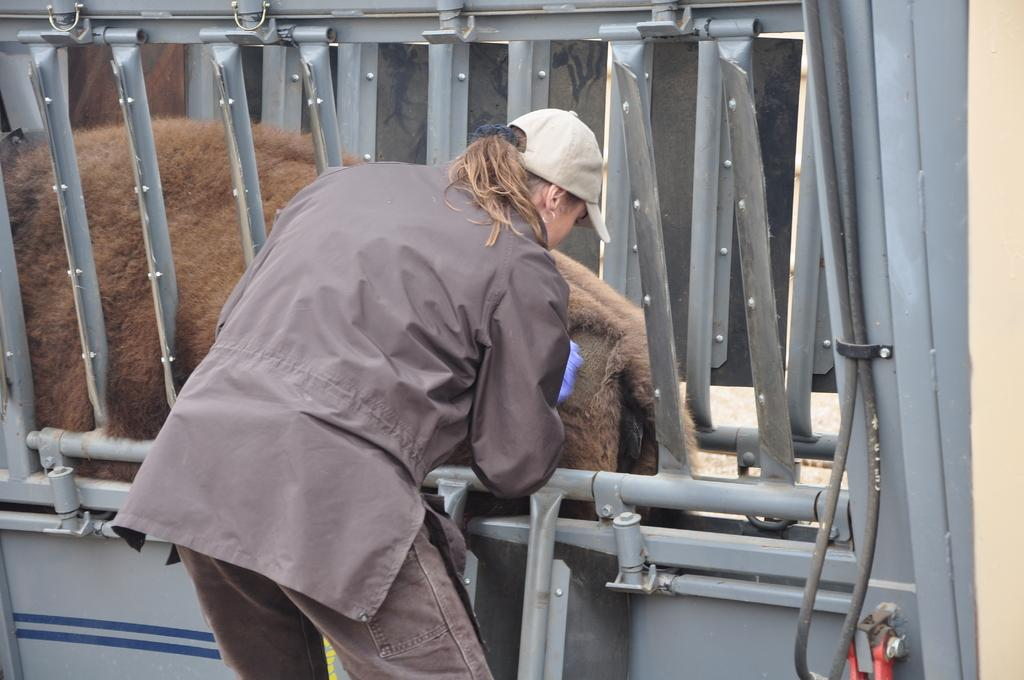Who is present in the image? There is a person in the image. What is the person wearing on their head? The person is wearing a cap. What other living creature is in the image? There is an animal in the image. What type of objects can be seen in the image? There are rods in the image. Can you tell me who won the argument in the image? There is no argument present in the image. 